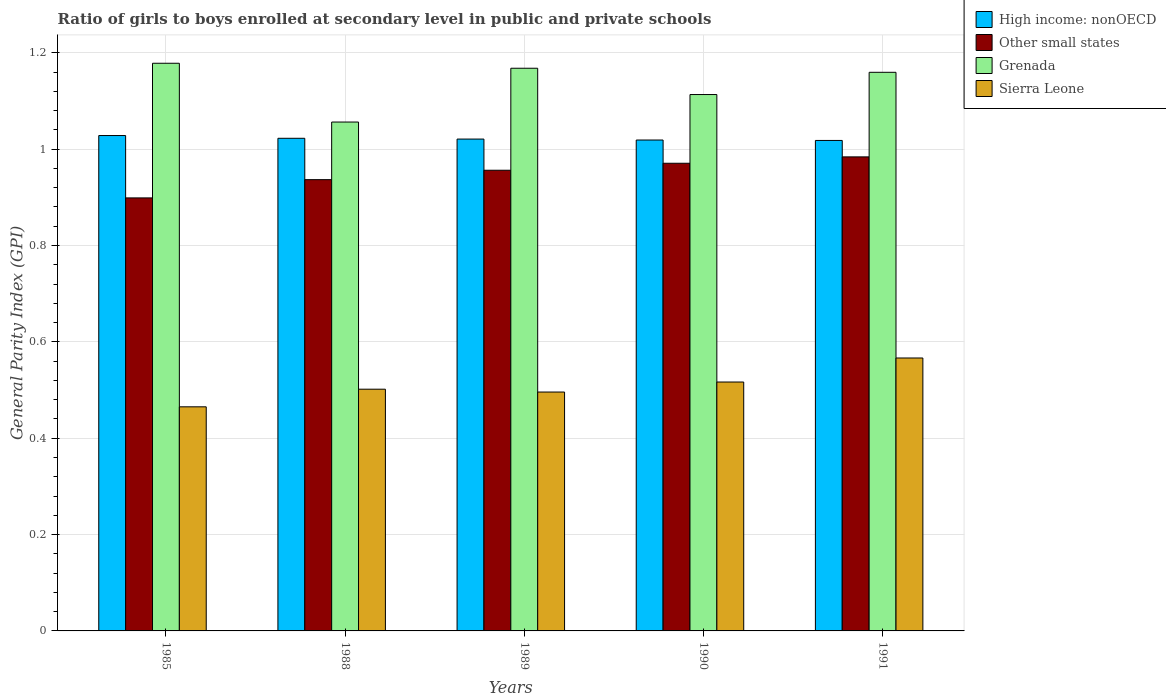How many groups of bars are there?
Your answer should be compact. 5. Are the number of bars on each tick of the X-axis equal?
Your answer should be compact. Yes. How many bars are there on the 4th tick from the right?
Provide a succinct answer. 4. What is the general parity index in Grenada in 1989?
Ensure brevity in your answer.  1.17. Across all years, what is the maximum general parity index in High income: nonOECD?
Ensure brevity in your answer.  1.03. Across all years, what is the minimum general parity index in Sierra Leone?
Offer a terse response. 0.47. In which year was the general parity index in Grenada maximum?
Your response must be concise. 1985. In which year was the general parity index in Other small states minimum?
Offer a terse response. 1985. What is the total general parity index in Other small states in the graph?
Keep it short and to the point. 4.75. What is the difference between the general parity index in Grenada in 1990 and that in 1991?
Offer a very short reply. -0.05. What is the difference between the general parity index in Grenada in 1991 and the general parity index in Sierra Leone in 1990?
Your response must be concise. 0.64. What is the average general parity index in Other small states per year?
Ensure brevity in your answer.  0.95. In the year 1990, what is the difference between the general parity index in Sierra Leone and general parity index in High income: nonOECD?
Make the answer very short. -0.5. What is the ratio of the general parity index in Grenada in 1988 to that in 1990?
Your answer should be compact. 0.95. Is the difference between the general parity index in Sierra Leone in 1988 and 1990 greater than the difference between the general parity index in High income: nonOECD in 1988 and 1990?
Your answer should be very brief. No. What is the difference between the highest and the second highest general parity index in Sierra Leone?
Your response must be concise. 0.05. What is the difference between the highest and the lowest general parity index in Sierra Leone?
Your answer should be very brief. 0.1. In how many years, is the general parity index in Other small states greater than the average general parity index in Other small states taken over all years?
Keep it short and to the point. 3. Is the sum of the general parity index in High income: nonOECD in 1988 and 1991 greater than the maximum general parity index in Other small states across all years?
Your answer should be compact. Yes. What does the 4th bar from the left in 1985 represents?
Your answer should be very brief. Sierra Leone. What does the 2nd bar from the right in 1988 represents?
Offer a terse response. Grenada. Is it the case that in every year, the sum of the general parity index in Grenada and general parity index in Other small states is greater than the general parity index in High income: nonOECD?
Make the answer very short. Yes. What is the difference between two consecutive major ticks on the Y-axis?
Offer a terse response. 0.2. Where does the legend appear in the graph?
Offer a very short reply. Top right. How are the legend labels stacked?
Give a very brief answer. Vertical. What is the title of the graph?
Keep it short and to the point. Ratio of girls to boys enrolled at secondary level in public and private schools. Does "Mauritania" appear as one of the legend labels in the graph?
Offer a terse response. No. What is the label or title of the X-axis?
Provide a succinct answer. Years. What is the label or title of the Y-axis?
Keep it short and to the point. General Parity Index (GPI). What is the General Parity Index (GPI) in High income: nonOECD in 1985?
Ensure brevity in your answer.  1.03. What is the General Parity Index (GPI) of Other small states in 1985?
Make the answer very short. 0.9. What is the General Parity Index (GPI) of Grenada in 1985?
Provide a succinct answer. 1.18. What is the General Parity Index (GPI) of Sierra Leone in 1985?
Offer a terse response. 0.47. What is the General Parity Index (GPI) in High income: nonOECD in 1988?
Offer a terse response. 1.02. What is the General Parity Index (GPI) of Other small states in 1988?
Your answer should be very brief. 0.94. What is the General Parity Index (GPI) in Grenada in 1988?
Provide a succinct answer. 1.06. What is the General Parity Index (GPI) of Sierra Leone in 1988?
Provide a succinct answer. 0.5. What is the General Parity Index (GPI) in High income: nonOECD in 1989?
Keep it short and to the point. 1.02. What is the General Parity Index (GPI) of Other small states in 1989?
Your response must be concise. 0.96. What is the General Parity Index (GPI) of Grenada in 1989?
Your answer should be very brief. 1.17. What is the General Parity Index (GPI) in Sierra Leone in 1989?
Your answer should be very brief. 0.5. What is the General Parity Index (GPI) in High income: nonOECD in 1990?
Provide a short and direct response. 1.02. What is the General Parity Index (GPI) of Other small states in 1990?
Offer a very short reply. 0.97. What is the General Parity Index (GPI) of Grenada in 1990?
Your answer should be compact. 1.11. What is the General Parity Index (GPI) of Sierra Leone in 1990?
Offer a terse response. 0.52. What is the General Parity Index (GPI) of High income: nonOECD in 1991?
Your response must be concise. 1.02. What is the General Parity Index (GPI) of Other small states in 1991?
Offer a terse response. 0.98. What is the General Parity Index (GPI) of Grenada in 1991?
Your response must be concise. 1.16. What is the General Parity Index (GPI) of Sierra Leone in 1991?
Your response must be concise. 0.57. Across all years, what is the maximum General Parity Index (GPI) in High income: nonOECD?
Offer a very short reply. 1.03. Across all years, what is the maximum General Parity Index (GPI) of Other small states?
Give a very brief answer. 0.98. Across all years, what is the maximum General Parity Index (GPI) in Grenada?
Your answer should be very brief. 1.18. Across all years, what is the maximum General Parity Index (GPI) of Sierra Leone?
Ensure brevity in your answer.  0.57. Across all years, what is the minimum General Parity Index (GPI) of High income: nonOECD?
Your answer should be very brief. 1.02. Across all years, what is the minimum General Parity Index (GPI) of Other small states?
Your answer should be compact. 0.9. Across all years, what is the minimum General Parity Index (GPI) in Grenada?
Give a very brief answer. 1.06. Across all years, what is the minimum General Parity Index (GPI) of Sierra Leone?
Your response must be concise. 0.47. What is the total General Parity Index (GPI) of High income: nonOECD in the graph?
Offer a terse response. 5.11. What is the total General Parity Index (GPI) of Other small states in the graph?
Provide a short and direct response. 4.75. What is the total General Parity Index (GPI) in Grenada in the graph?
Provide a succinct answer. 5.67. What is the total General Parity Index (GPI) of Sierra Leone in the graph?
Keep it short and to the point. 2.55. What is the difference between the General Parity Index (GPI) in High income: nonOECD in 1985 and that in 1988?
Your answer should be very brief. 0.01. What is the difference between the General Parity Index (GPI) of Other small states in 1985 and that in 1988?
Give a very brief answer. -0.04. What is the difference between the General Parity Index (GPI) in Grenada in 1985 and that in 1988?
Your answer should be very brief. 0.12. What is the difference between the General Parity Index (GPI) of Sierra Leone in 1985 and that in 1988?
Keep it short and to the point. -0.04. What is the difference between the General Parity Index (GPI) in High income: nonOECD in 1985 and that in 1989?
Your answer should be compact. 0.01. What is the difference between the General Parity Index (GPI) of Other small states in 1985 and that in 1989?
Provide a succinct answer. -0.06. What is the difference between the General Parity Index (GPI) in Grenada in 1985 and that in 1989?
Provide a succinct answer. 0.01. What is the difference between the General Parity Index (GPI) of Sierra Leone in 1985 and that in 1989?
Give a very brief answer. -0.03. What is the difference between the General Parity Index (GPI) in High income: nonOECD in 1985 and that in 1990?
Keep it short and to the point. 0.01. What is the difference between the General Parity Index (GPI) in Other small states in 1985 and that in 1990?
Provide a short and direct response. -0.07. What is the difference between the General Parity Index (GPI) in Grenada in 1985 and that in 1990?
Make the answer very short. 0.06. What is the difference between the General Parity Index (GPI) of Sierra Leone in 1985 and that in 1990?
Make the answer very short. -0.05. What is the difference between the General Parity Index (GPI) of High income: nonOECD in 1985 and that in 1991?
Make the answer very short. 0.01. What is the difference between the General Parity Index (GPI) of Other small states in 1985 and that in 1991?
Your response must be concise. -0.09. What is the difference between the General Parity Index (GPI) in Grenada in 1985 and that in 1991?
Give a very brief answer. 0.02. What is the difference between the General Parity Index (GPI) of Sierra Leone in 1985 and that in 1991?
Provide a short and direct response. -0.1. What is the difference between the General Parity Index (GPI) in High income: nonOECD in 1988 and that in 1989?
Offer a very short reply. 0. What is the difference between the General Parity Index (GPI) in Other small states in 1988 and that in 1989?
Keep it short and to the point. -0.02. What is the difference between the General Parity Index (GPI) of Grenada in 1988 and that in 1989?
Give a very brief answer. -0.11. What is the difference between the General Parity Index (GPI) in Sierra Leone in 1988 and that in 1989?
Make the answer very short. 0.01. What is the difference between the General Parity Index (GPI) of High income: nonOECD in 1988 and that in 1990?
Offer a terse response. 0. What is the difference between the General Parity Index (GPI) of Other small states in 1988 and that in 1990?
Offer a terse response. -0.03. What is the difference between the General Parity Index (GPI) of Grenada in 1988 and that in 1990?
Offer a terse response. -0.06. What is the difference between the General Parity Index (GPI) in Sierra Leone in 1988 and that in 1990?
Your answer should be very brief. -0.01. What is the difference between the General Parity Index (GPI) of High income: nonOECD in 1988 and that in 1991?
Offer a terse response. 0. What is the difference between the General Parity Index (GPI) of Other small states in 1988 and that in 1991?
Your answer should be very brief. -0.05. What is the difference between the General Parity Index (GPI) in Grenada in 1988 and that in 1991?
Provide a short and direct response. -0.1. What is the difference between the General Parity Index (GPI) of Sierra Leone in 1988 and that in 1991?
Keep it short and to the point. -0.06. What is the difference between the General Parity Index (GPI) of High income: nonOECD in 1989 and that in 1990?
Make the answer very short. 0. What is the difference between the General Parity Index (GPI) in Other small states in 1989 and that in 1990?
Offer a very short reply. -0.01. What is the difference between the General Parity Index (GPI) in Grenada in 1989 and that in 1990?
Your answer should be very brief. 0.05. What is the difference between the General Parity Index (GPI) of Sierra Leone in 1989 and that in 1990?
Offer a terse response. -0.02. What is the difference between the General Parity Index (GPI) in High income: nonOECD in 1989 and that in 1991?
Ensure brevity in your answer.  0. What is the difference between the General Parity Index (GPI) of Other small states in 1989 and that in 1991?
Your response must be concise. -0.03. What is the difference between the General Parity Index (GPI) in Grenada in 1989 and that in 1991?
Ensure brevity in your answer.  0.01. What is the difference between the General Parity Index (GPI) of Sierra Leone in 1989 and that in 1991?
Offer a very short reply. -0.07. What is the difference between the General Parity Index (GPI) in High income: nonOECD in 1990 and that in 1991?
Offer a terse response. 0. What is the difference between the General Parity Index (GPI) in Other small states in 1990 and that in 1991?
Keep it short and to the point. -0.01. What is the difference between the General Parity Index (GPI) in Grenada in 1990 and that in 1991?
Provide a short and direct response. -0.05. What is the difference between the General Parity Index (GPI) in Sierra Leone in 1990 and that in 1991?
Provide a short and direct response. -0.05. What is the difference between the General Parity Index (GPI) in High income: nonOECD in 1985 and the General Parity Index (GPI) in Other small states in 1988?
Ensure brevity in your answer.  0.09. What is the difference between the General Parity Index (GPI) of High income: nonOECD in 1985 and the General Parity Index (GPI) of Grenada in 1988?
Provide a short and direct response. -0.03. What is the difference between the General Parity Index (GPI) in High income: nonOECD in 1985 and the General Parity Index (GPI) in Sierra Leone in 1988?
Provide a short and direct response. 0.53. What is the difference between the General Parity Index (GPI) of Other small states in 1985 and the General Parity Index (GPI) of Grenada in 1988?
Your answer should be compact. -0.16. What is the difference between the General Parity Index (GPI) in Other small states in 1985 and the General Parity Index (GPI) in Sierra Leone in 1988?
Keep it short and to the point. 0.4. What is the difference between the General Parity Index (GPI) in Grenada in 1985 and the General Parity Index (GPI) in Sierra Leone in 1988?
Provide a short and direct response. 0.68. What is the difference between the General Parity Index (GPI) of High income: nonOECD in 1985 and the General Parity Index (GPI) of Other small states in 1989?
Keep it short and to the point. 0.07. What is the difference between the General Parity Index (GPI) of High income: nonOECD in 1985 and the General Parity Index (GPI) of Grenada in 1989?
Keep it short and to the point. -0.14. What is the difference between the General Parity Index (GPI) of High income: nonOECD in 1985 and the General Parity Index (GPI) of Sierra Leone in 1989?
Ensure brevity in your answer.  0.53. What is the difference between the General Parity Index (GPI) of Other small states in 1985 and the General Parity Index (GPI) of Grenada in 1989?
Ensure brevity in your answer.  -0.27. What is the difference between the General Parity Index (GPI) in Other small states in 1985 and the General Parity Index (GPI) in Sierra Leone in 1989?
Your response must be concise. 0.4. What is the difference between the General Parity Index (GPI) of Grenada in 1985 and the General Parity Index (GPI) of Sierra Leone in 1989?
Provide a succinct answer. 0.68. What is the difference between the General Parity Index (GPI) of High income: nonOECD in 1985 and the General Parity Index (GPI) of Other small states in 1990?
Provide a short and direct response. 0.06. What is the difference between the General Parity Index (GPI) of High income: nonOECD in 1985 and the General Parity Index (GPI) of Grenada in 1990?
Give a very brief answer. -0.09. What is the difference between the General Parity Index (GPI) of High income: nonOECD in 1985 and the General Parity Index (GPI) of Sierra Leone in 1990?
Give a very brief answer. 0.51. What is the difference between the General Parity Index (GPI) in Other small states in 1985 and the General Parity Index (GPI) in Grenada in 1990?
Provide a succinct answer. -0.21. What is the difference between the General Parity Index (GPI) in Other small states in 1985 and the General Parity Index (GPI) in Sierra Leone in 1990?
Your answer should be compact. 0.38. What is the difference between the General Parity Index (GPI) of Grenada in 1985 and the General Parity Index (GPI) of Sierra Leone in 1990?
Provide a succinct answer. 0.66. What is the difference between the General Parity Index (GPI) in High income: nonOECD in 1985 and the General Parity Index (GPI) in Other small states in 1991?
Give a very brief answer. 0.04. What is the difference between the General Parity Index (GPI) in High income: nonOECD in 1985 and the General Parity Index (GPI) in Grenada in 1991?
Ensure brevity in your answer.  -0.13. What is the difference between the General Parity Index (GPI) of High income: nonOECD in 1985 and the General Parity Index (GPI) of Sierra Leone in 1991?
Ensure brevity in your answer.  0.46. What is the difference between the General Parity Index (GPI) in Other small states in 1985 and the General Parity Index (GPI) in Grenada in 1991?
Your response must be concise. -0.26. What is the difference between the General Parity Index (GPI) in Other small states in 1985 and the General Parity Index (GPI) in Sierra Leone in 1991?
Provide a succinct answer. 0.33. What is the difference between the General Parity Index (GPI) in Grenada in 1985 and the General Parity Index (GPI) in Sierra Leone in 1991?
Your response must be concise. 0.61. What is the difference between the General Parity Index (GPI) in High income: nonOECD in 1988 and the General Parity Index (GPI) in Other small states in 1989?
Provide a short and direct response. 0.07. What is the difference between the General Parity Index (GPI) of High income: nonOECD in 1988 and the General Parity Index (GPI) of Grenada in 1989?
Your answer should be compact. -0.15. What is the difference between the General Parity Index (GPI) in High income: nonOECD in 1988 and the General Parity Index (GPI) in Sierra Leone in 1989?
Your response must be concise. 0.53. What is the difference between the General Parity Index (GPI) of Other small states in 1988 and the General Parity Index (GPI) of Grenada in 1989?
Your answer should be compact. -0.23. What is the difference between the General Parity Index (GPI) in Other small states in 1988 and the General Parity Index (GPI) in Sierra Leone in 1989?
Your answer should be very brief. 0.44. What is the difference between the General Parity Index (GPI) in Grenada in 1988 and the General Parity Index (GPI) in Sierra Leone in 1989?
Provide a succinct answer. 0.56. What is the difference between the General Parity Index (GPI) in High income: nonOECD in 1988 and the General Parity Index (GPI) in Other small states in 1990?
Provide a succinct answer. 0.05. What is the difference between the General Parity Index (GPI) of High income: nonOECD in 1988 and the General Parity Index (GPI) of Grenada in 1990?
Offer a very short reply. -0.09. What is the difference between the General Parity Index (GPI) of High income: nonOECD in 1988 and the General Parity Index (GPI) of Sierra Leone in 1990?
Your answer should be very brief. 0.51. What is the difference between the General Parity Index (GPI) in Other small states in 1988 and the General Parity Index (GPI) in Grenada in 1990?
Provide a succinct answer. -0.18. What is the difference between the General Parity Index (GPI) in Other small states in 1988 and the General Parity Index (GPI) in Sierra Leone in 1990?
Provide a short and direct response. 0.42. What is the difference between the General Parity Index (GPI) of Grenada in 1988 and the General Parity Index (GPI) of Sierra Leone in 1990?
Make the answer very short. 0.54. What is the difference between the General Parity Index (GPI) in High income: nonOECD in 1988 and the General Parity Index (GPI) in Other small states in 1991?
Your answer should be compact. 0.04. What is the difference between the General Parity Index (GPI) in High income: nonOECD in 1988 and the General Parity Index (GPI) in Grenada in 1991?
Give a very brief answer. -0.14. What is the difference between the General Parity Index (GPI) in High income: nonOECD in 1988 and the General Parity Index (GPI) in Sierra Leone in 1991?
Offer a very short reply. 0.46. What is the difference between the General Parity Index (GPI) in Other small states in 1988 and the General Parity Index (GPI) in Grenada in 1991?
Offer a terse response. -0.22. What is the difference between the General Parity Index (GPI) in Other small states in 1988 and the General Parity Index (GPI) in Sierra Leone in 1991?
Provide a succinct answer. 0.37. What is the difference between the General Parity Index (GPI) of Grenada in 1988 and the General Parity Index (GPI) of Sierra Leone in 1991?
Make the answer very short. 0.49. What is the difference between the General Parity Index (GPI) in High income: nonOECD in 1989 and the General Parity Index (GPI) in Other small states in 1990?
Keep it short and to the point. 0.05. What is the difference between the General Parity Index (GPI) of High income: nonOECD in 1989 and the General Parity Index (GPI) of Grenada in 1990?
Offer a terse response. -0.09. What is the difference between the General Parity Index (GPI) of High income: nonOECD in 1989 and the General Parity Index (GPI) of Sierra Leone in 1990?
Ensure brevity in your answer.  0.5. What is the difference between the General Parity Index (GPI) of Other small states in 1989 and the General Parity Index (GPI) of Grenada in 1990?
Your response must be concise. -0.16. What is the difference between the General Parity Index (GPI) in Other small states in 1989 and the General Parity Index (GPI) in Sierra Leone in 1990?
Keep it short and to the point. 0.44. What is the difference between the General Parity Index (GPI) in Grenada in 1989 and the General Parity Index (GPI) in Sierra Leone in 1990?
Provide a succinct answer. 0.65. What is the difference between the General Parity Index (GPI) of High income: nonOECD in 1989 and the General Parity Index (GPI) of Other small states in 1991?
Provide a succinct answer. 0.04. What is the difference between the General Parity Index (GPI) of High income: nonOECD in 1989 and the General Parity Index (GPI) of Grenada in 1991?
Provide a succinct answer. -0.14. What is the difference between the General Parity Index (GPI) in High income: nonOECD in 1989 and the General Parity Index (GPI) in Sierra Leone in 1991?
Your answer should be very brief. 0.45. What is the difference between the General Parity Index (GPI) of Other small states in 1989 and the General Parity Index (GPI) of Grenada in 1991?
Offer a terse response. -0.2. What is the difference between the General Parity Index (GPI) of Other small states in 1989 and the General Parity Index (GPI) of Sierra Leone in 1991?
Your answer should be very brief. 0.39. What is the difference between the General Parity Index (GPI) of Grenada in 1989 and the General Parity Index (GPI) of Sierra Leone in 1991?
Provide a short and direct response. 0.6. What is the difference between the General Parity Index (GPI) in High income: nonOECD in 1990 and the General Parity Index (GPI) in Other small states in 1991?
Your answer should be very brief. 0.04. What is the difference between the General Parity Index (GPI) of High income: nonOECD in 1990 and the General Parity Index (GPI) of Grenada in 1991?
Your response must be concise. -0.14. What is the difference between the General Parity Index (GPI) of High income: nonOECD in 1990 and the General Parity Index (GPI) of Sierra Leone in 1991?
Give a very brief answer. 0.45. What is the difference between the General Parity Index (GPI) of Other small states in 1990 and the General Parity Index (GPI) of Grenada in 1991?
Provide a short and direct response. -0.19. What is the difference between the General Parity Index (GPI) of Other small states in 1990 and the General Parity Index (GPI) of Sierra Leone in 1991?
Provide a succinct answer. 0.4. What is the difference between the General Parity Index (GPI) of Grenada in 1990 and the General Parity Index (GPI) of Sierra Leone in 1991?
Make the answer very short. 0.55. What is the average General Parity Index (GPI) in High income: nonOECD per year?
Your answer should be very brief. 1.02. What is the average General Parity Index (GPI) of Other small states per year?
Keep it short and to the point. 0.95. What is the average General Parity Index (GPI) of Grenada per year?
Your answer should be very brief. 1.14. What is the average General Parity Index (GPI) of Sierra Leone per year?
Your response must be concise. 0.51. In the year 1985, what is the difference between the General Parity Index (GPI) of High income: nonOECD and General Parity Index (GPI) of Other small states?
Give a very brief answer. 0.13. In the year 1985, what is the difference between the General Parity Index (GPI) of High income: nonOECD and General Parity Index (GPI) of Grenada?
Keep it short and to the point. -0.15. In the year 1985, what is the difference between the General Parity Index (GPI) in High income: nonOECD and General Parity Index (GPI) in Sierra Leone?
Offer a very short reply. 0.56. In the year 1985, what is the difference between the General Parity Index (GPI) of Other small states and General Parity Index (GPI) of Grenada?
Provide a succinct answer. -0.28. In the year 1985, what is the difference between the General Parity Index (GPI) in Other small states and General Parity Index (GPI) in Sierra Leone?
Ensure brevity in your answer.  0.43. In the year 1985, what is the difference between the General Parity Index (GPI) of Grenada and General Parity Index (GPI) of Sierra Leone?
Your answer should be very brief. 0.71. In the year 1988, what is the difference between the General Parity Index (GPI) of High income: nonOECD and General Parity Index (GPI) of Other small states?
Offer a very short reply. 0.09. In the year 1988, what is the difference between the General Parity Index (GPI) in High income: nonOECD and General Parity Index (GPI) in Grenada?
Your answer should be compact. -0.03. In the year 1988, what is the difference between the General Parity Index (GPI) in High income: nonOECD and General Parity Index (GPI) in Sierra Leone?
Provide a short and direct response. 0.52. In the year 1988, what is the difference between the General Parity Index (GPI) of Other small states and General Parity Index (GPI) of Grenada?
Ensure brevity in your answer.  -0.12. In the year 1988, what is the difference between the General Parity Index (GPI) in Other small states and General Parity Index (GPI) in Sierra Leone?
Your answer should be very brief. 0.43. In the year 1988, what is the difference between the General Parity Index (GPI) in Grenada and General Parity Index (GPI) in Sierra Leone?
Your answer should be compact. 0.55. In the year 1989, what is the difference between the General Parity Index (GPI) of High income: nonOECD and General Parity Index (GPI) of Other small states?
Ensure brevity in your answer.  0.06. In the year 1989, what is the difference between the General Parity Index (GPI) in High income: nonOECD and General Parity Index (GPI) in Grenada?
Your answer should be compact. -0.15. In the year 1989, what is the difference between the General Parity Index (GPI) of High income: nonOECD and General Parity Index (GPI) of Sierra Leone?
Your answer should be very brief. 0.53. In the year 1989, what is the difference between the General Parity Index (GPI) in Other small states and General Parity Index (GPI) in Grenada?
Provide a succinct answer. -0.21. In the year 1989, what is the difference between the General Parity Index (GPI) in Other small states and General Parity Index (GPI) in Sierra Leone?
Your response must be concise. 0.46. In the year 1989, what is the difference between the General Parity Index (GPI) in Grenada and General Parity Index (GPI) in Sierra Leone?
Give a very brief answer. 0.67. In the year 1990, what is the difference between the General Parity Index (GPI) of High income: nonOECD and General Parity Index (GPI) of Other small states?
Provide a succinct answer. 0.05. In the year 1990, what is the difference between the General Parity Index (GPI) of High income: nonOECD and General Parity Index (GPI) of Grenada?
Make the answer very short. -0.09. In the year 1990, what is the difference between the General Parity Index (GPI) in High income: nonOECD and General Parity Index (GPI) in Sierra Leone?
Your answer should be compact. 0.5. In the year 1990, what is the difference between the General Parity Index (GPI) in Other small states and General Parity Index (GPI) in Grenada?
Keep it short and to the point. -0.14. In the year 1990, what is the difference between the General Parity Index (GPI) of Other small states and General Parity Index (GPI) of Sierra Leone?
Offer a terse response. 0.45. In the year 1990, what is the difference between the General Parity Index (GPI) in Grenada and General Parity Index (GPI) in Sierra Leone?
Your answer should be very brief. 0.6. In the year 1991, what is the difference between the General Parity Index (GPI) of High income: nonOECD and General Parity Index (GPI) of Other small states?
Ensure brevity in your answer.  0.03. In the year 1991, what is the difference between the General Parity Index (GPI) of High income: nonOECD and General Parity Index (GPI) of Grenada?
Offer a very short reply. -0.14. In the year 1991, what is the difference between the General Parity Index (GPI) in High income: nonOECD and General Parity Index (GPI) in Sierra Leone?
Keep it short and to the point. 0.45. In the year 1991, what is the difference between the General Parity Index (GPI) of Other small states and General Parity Index (GPI) of Grenada?
Provide a short and direct response. -0.18. In the year 1991, what is the difference between the General Parity Index (GPI) of Other small states and General Parity Index (GPI) of Sierra Leone?
Ensure brevity in your answer.  0.42. In the year 1991, what is the difference between the General Parity Index (GPI) in Grenada and General Parity Index (GPI) in Sierra Leone?
Your answer should be compact. 0.59. What is the ratio of the General Parity Index (GPI) of High income: nonOECD in 1985 to that in 1988?
Provide a short and direct response. 1.01. What is the ratio of the General Parity Index (GPI) of Other small states in 1985 to that in 1988?
Provide a succinct answer. 0.96. What is the ratio of the General Parity Index (GPI) in Grenada in 1985 to that in 1988?
Your response must be concise. 1.12. What is the ratio of the General Parity Index (GPI) in Sierra Leone in 1985 to that in 1988?
Offer a very short reply. 0.93. What is the ratio of the General Parity Index (GPI) in Grenada in 1985 to that in 1989?
Your answer should be very brief. 1.01. What is the ratio of the General Parity Index (GPI) of Sierra Leone in 1985 to that in 1989?
Offer a terse response. 0.94. What is the ratio of the General Parity Index (GPI) in High income: nonOECD in 1985 to that in 1990?
Offer a terse response. 1.01. What is the ratio of the General Parity Index (GPI) in Other small states in 1985 to that in 1990?
Your response must be concise. 0.93. What is the ratio of the General Parity Index (GPI) in Grenada in 1985 to that in 1990?
Ensure brevity in your answer.  1.06. What is the ratio of the General Parity Index (GPI) of Sierra Leone in 1985 to that in 1990?
Offer a terse response. 0.9. What is the ratio of the General Parity Index (GPI) in Other small states in 1985 to that in 1991?
Offer a very short reply. 0.91. What is the ratio of the General Parity Index (GPI) in Grenada in 1985 to that in 1991?
Offer a terse response. 1.02. What is the ratio of the General Parity Index (GPI) of Sierra Leone in 1985 to that in 1991?
Give a very brief answer. 0.82. What is the ratio of the General Parity Index (GPI) of High income: nonOECD in 1988 to that in 1989?
Provide a short and direct response. 1. What is the ratio of the General Parity Index (GPI) in Other small states in 1988 to that in 1989?
Keep it short and to the point. 0.98. What is the ratio of the General Parity Index (GPI) in Grenada in 1988 to that in 1989?
Offer a very short reply. 0.9. What is the ratio of the General Parity Index (GPI) of Sierra Leone in 1988 to that in 1989?
Give a very brief answer. 1.01. What is the ratio of the General Parity Index (GPI) in Other small states in 1988 to that in 1990?
Ensure brevity in your answer.  0.96. What is the ratio of the General Parity Index (GPI) of Grenada in 1988 to that in 1990?
Offer a terse response. 0.95. What is the ratio of the General Parity Index (GPI) in Sierra Leone in 1988 to that in 1990?
Give a very brief answer. 0.97. What is the ratio of the General Parity Index (GPI) of High income: nonOECD in 1988 to that in 1991?
Your response must be concise. 1. What is the ratio of the General Parity Index (GPI) in Grenada in 1988 to that in 1991?
Your answer should be compact. 0.91. What is the ratio of the General Parity Index (GPI) in Sierra Leone in 1988 to that in 1991?
Offer a terse response. 0.89. What is the ratio of the General Parity Index (GPI) of High income: nonOECD in 1989 to that in 1990?
Keep it short and to the point. 1. What is the ratio of the General Parity Index (GPI) in Other small states in 1989 to that in 1990?
Ensure brevity in your answer.  0.99. What is the ratio of the General Parity Index (GPI) of Grenada in 1989 to that in 1990?
Provide a succinct answer. 1.05. What is the ratio of the General Parity Index (GPI) of Sierra Leone in 1989 to that in 1990?
Make the answer very short. 0.96. What is the ratio of the General Parity Index (GPI) of High income: nonOECD in 1989 to that in 1991?
Provide a succinct answer. 1. What is the ratio of the General Parity Index (GPI) in Other small states in 1989 to that in 1991?
Provide a short and direct response. 0.97. What is the ratio of the General Parity Index (GPI) of Grenada in 1989 to that in 1991?
Provide a short and direct response. 1.01. What is the ratio of the General Parity Index (GPI) in Sierra Leone in 1989 to that in 1991?
Give a very brief answer. 0.88. What is the ratio of the General Parity Index (GPI) of Other small states in 1990 to that in 1991?
Your response must be concise. 0.99. What is the ratio of the General Parity Index (GPI) in Grenada in 1990 to that in 1991?
Provide a short and direct response. 0.96. What is the ratio of the General Parity Index (GPI) in Sierra Leone in 1990 to that in 1991?
Your response must be concise. 0.91. What is the difference between the highest and the second highest General Parity Index (GPI) of High income: nonOECD?
Your answer should be very brief. 0.01. What is the difference between the highest and the second highest General Parity Index (GPI) in Other small states?
Ensure brevity in your answer.  0.01. What is the difference between the highest and the second highest General Parity Index (GPI) of Grenada?
Your answer should be compact. 0.01. What is the difference between the highest and the second highest General Parity Index (GPI) in Sierra Leone?
Offer a very short reply. 0.05. What is the difference between the highest and the lowest General Parity Index (GPI) of High income: nonOECD?
Your answer should be very brief. 0.01. What is the difference between the highest and the lowest General Parity Index (GPI) in Other small states?
Keep it short and to the point. 0.09. What is the difference between the highest and the lowest General Parity Index (GPI) in Grenada?
Ensure brevity in your answer.  0.12. What is the difference between the highest and the lowest General Parity Index (GPI) in Sierra Leone?
Your response must be concise. 0.1. 